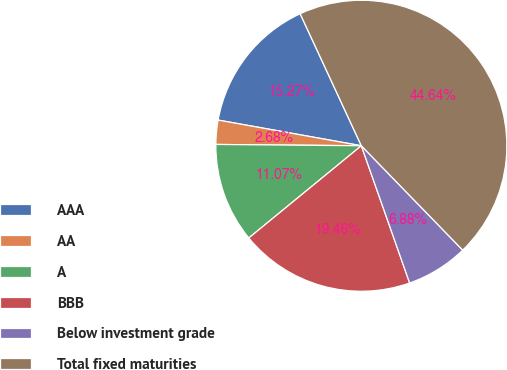Convert chart to OTSL. <chart><loc_0><loc_0><loc_500><loc_500><pie_chart><fcel>AAA<fcel>AA<fcel>A<fcel>BBB<fcel>Below investment grade<fcel>Total fixed maturities<nl><fcel>15.27%<fcel>2.68%<fcel>11.07%<fcel>19.46%<fcel>6.88%<fcel>44.64%<nl></chart> 